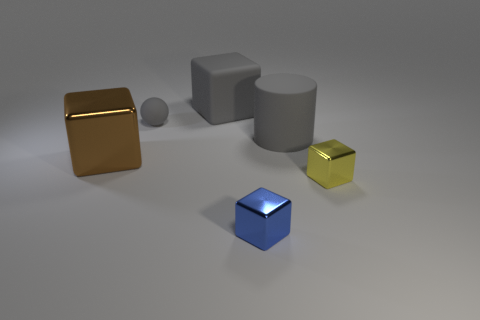Are there fewer large rubber blocks that are right of the rubber cube than rubber blocks that are behind the tiny gray ball?
Provide a succinct answer. Yes. The other tiny thing that is the same material as the tiny blue object is what shape?
Offer a very short reply. Cube. There is a matte object that is on the right side of the cube behind the large thing that is left of the large gray block; how big is it?
Your response must be concise. Large. Is the number of small matte spheres greater than the number of gray matte things?
Offer a terse response. No. Is the color of the shiny cube on the left side of the small blue cube the same as the big cube behind the brown metal cube?
Offer a terse response. No. Is the thing behind the small rubber ball made of the same material as the gray object that is right of the blue metallic cube?
Provide a short and direct response. Yes. How many brown metallic objects have the same size as the gray ball?
Your response must be concise. 0. Is the number of brown objects less than the number of metal objects?
Your response must be concise. Yes. There is a big gray rubber thing that is on the right side of the gray matte object behind the rubber sphere; what is its shape?
Make the answer very short. Cylinder. There is a brown object that is the same size as the matte cylinder; what is its shape?
Your answer should be very brief. Cube. 